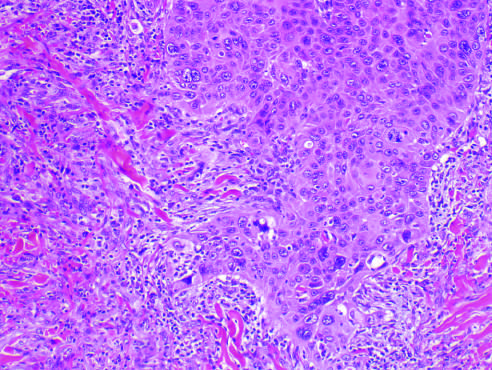what did irregular projections of atypical squamous cells exhibit?
Answer the question using a single word or phrase. Acantholysis 